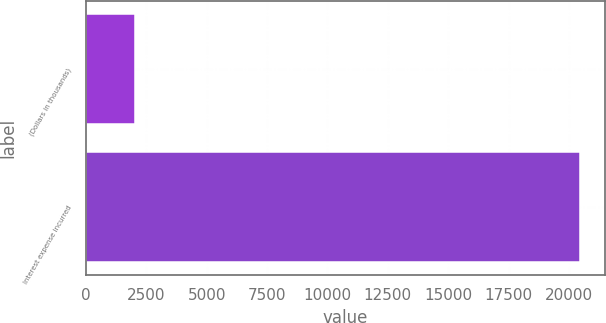Convert chart to OTSL. <chart><loc_0><loc_0><loc_500><loc_500><bar_chart><fcel>(Dollars in thousands)<fcel>Interest expense incurred<nl><fcel>2012<fcel>20454<nl></chart> 